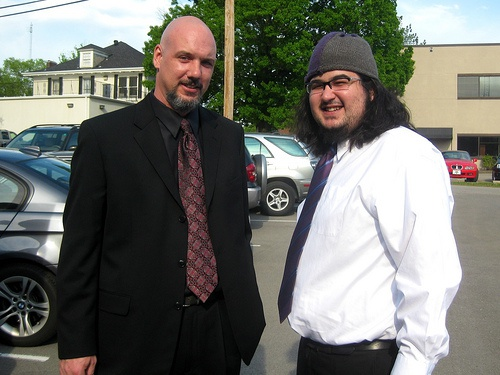Describe the objects in this image and their specific colors. I can see people in white, black, maroon, brown, and gray tones, people in white, black, gray, and darkgray tones, car in white, black, gray, darkgray, and lightgray tones, tie in white, maroon, black, and brown tones, and car in white, black, gray, and darkgray tones in this image. 